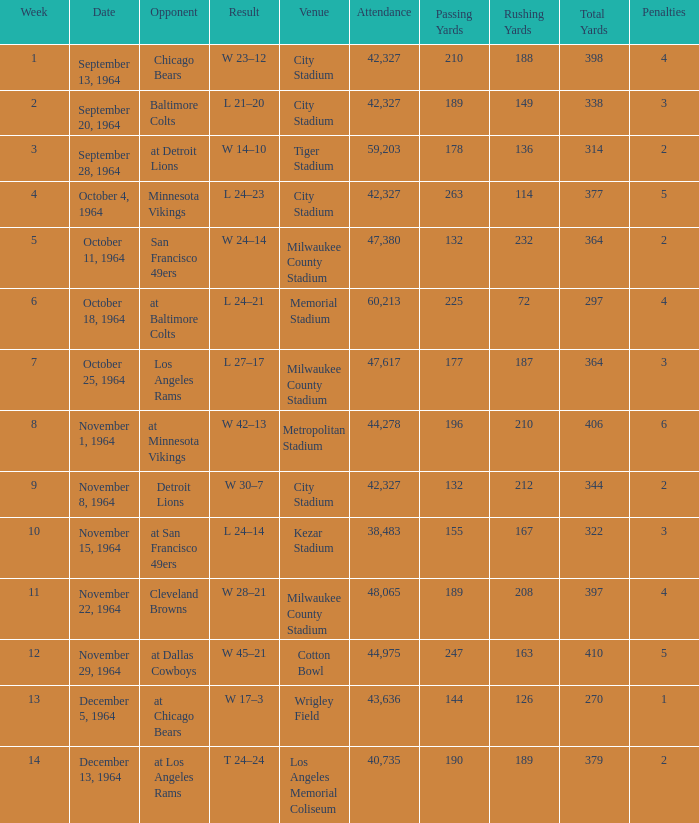What is the average attendance at a week 4 game? 42327.0. 